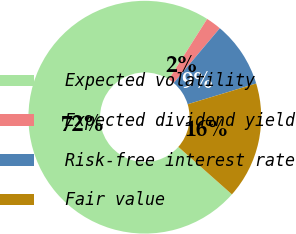<chart> <loc_0><loc_0><loc_500><loc_500><pie_chart><fcel>Expected volatility<fcel>Expected dividend yield<fcel>Risk-free interest rate<fcel>Fair value<nl><fcel>72.45%<fcel>2.15%<fcel>9.18%<fcel>16.21%<nl></chart> 